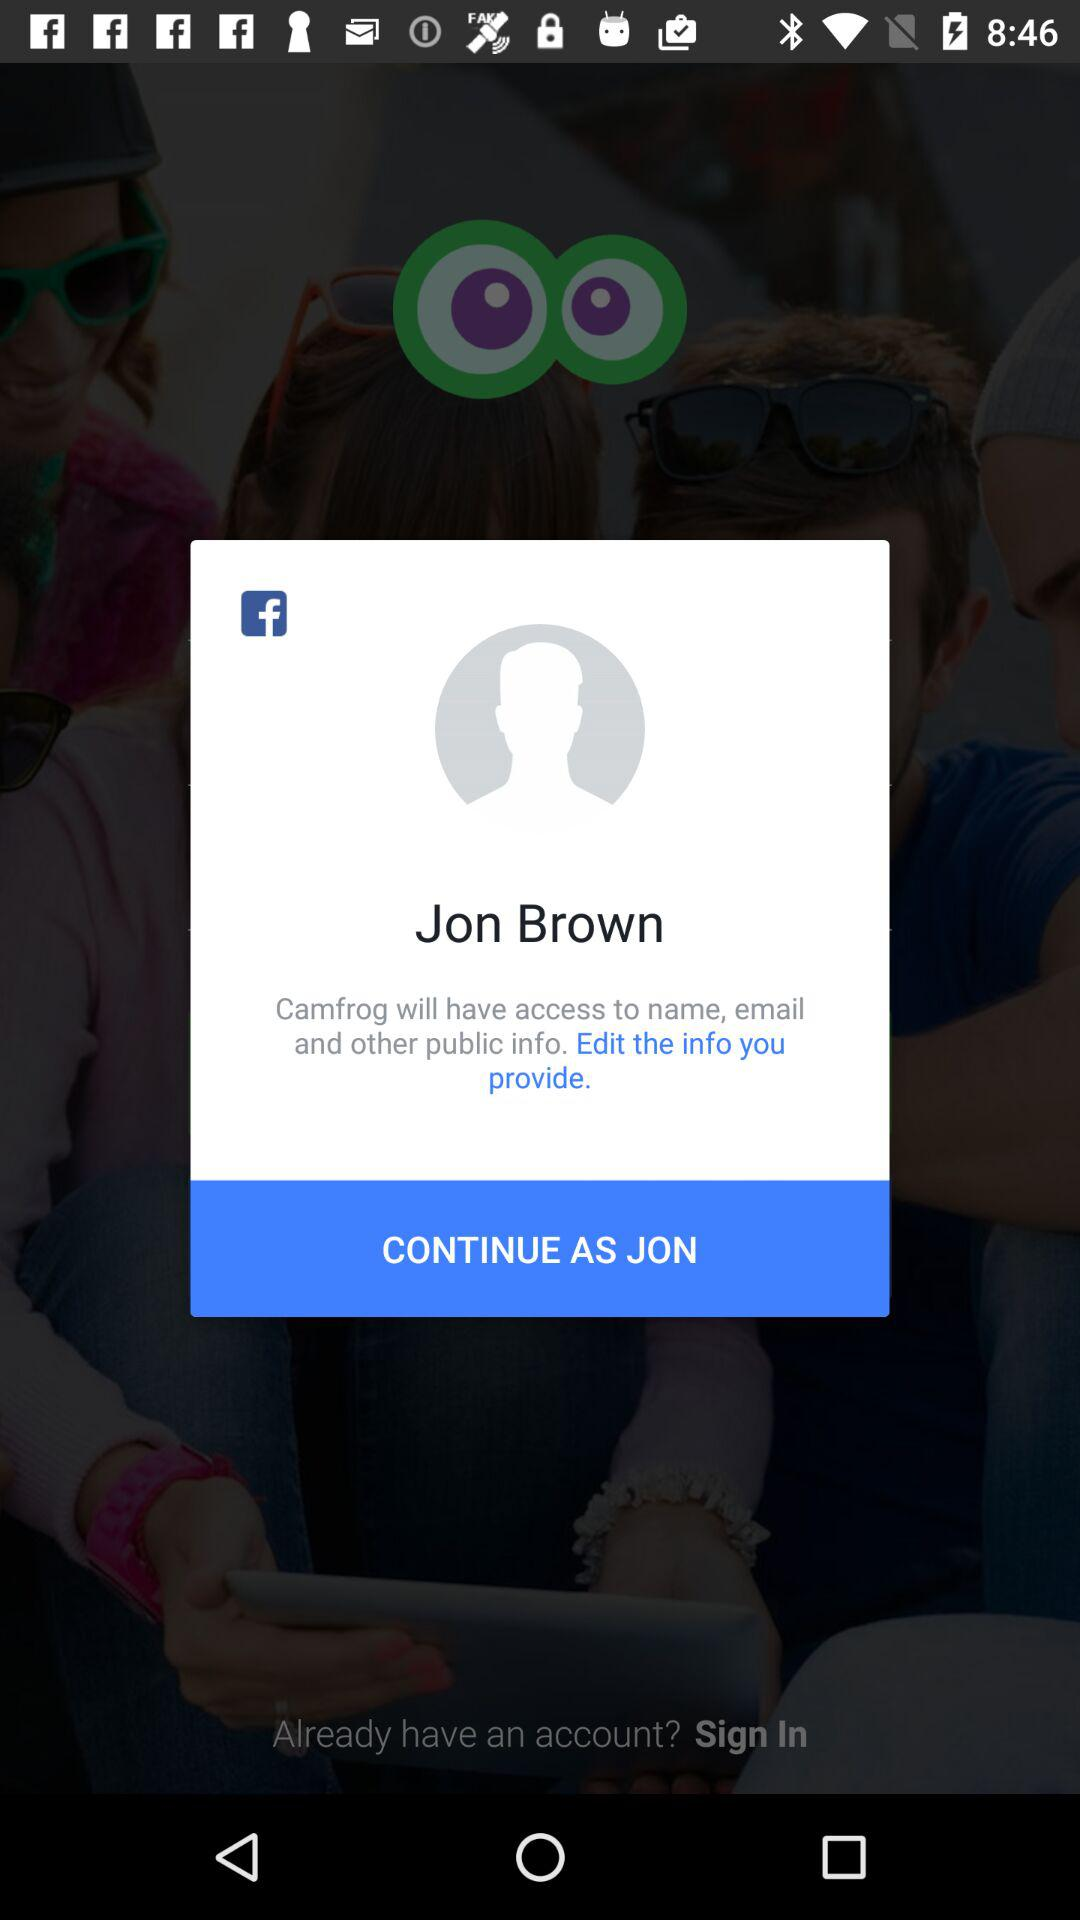What is the user name? The user name is Jon Brown. 